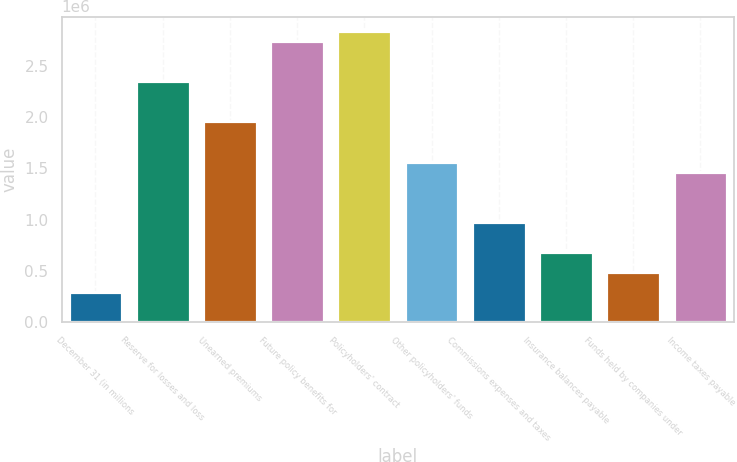Convert chart to OTSL. <chart><loc_0><loc_0><loc_500><loc_500><bar_chart><fcel>December 31 (in millions<fcel>Reserve for losses and loss<fcel>Unearned premiums<fcel>Future policy benefits for<fcel>Policyholders' contract<fcel>Other policyholders' funds<fcel>Commissions expenses and taxes<fcel>Insurance balances payable<fcel>Funds held by companies under<fcel>Income taxes payable<nl><fcel>293958<fcel>2.35033e+06<fcel>1.95864e+06<fcel>2.74202e+06<fcel>2.83994e+06<fcel>1.56695e+06<fcel>979414<fcel>685647<fcel>489802<fcel>1.46903e+06<nl></chart> 